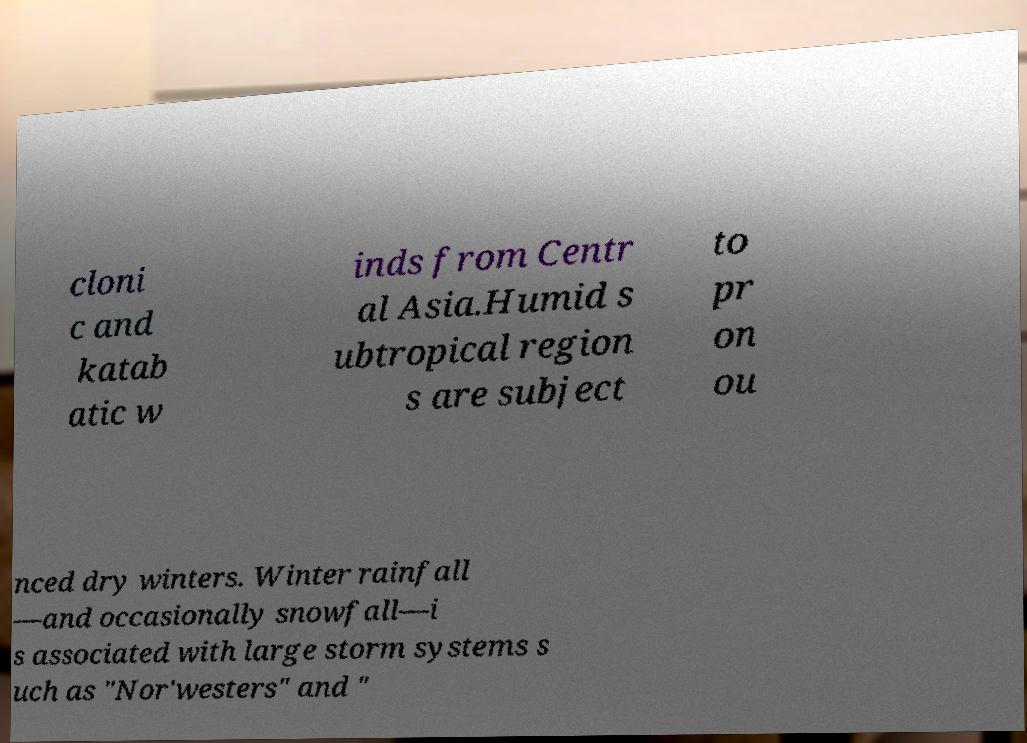Please identify and transcribe the text found in this image. cloni c and katab atic w inds from Centr al Asia.Humid s ubtropical region s are subject to pr on ou nced dry winters. Winter rainfall —and occasionally snowfall—i s associated with large storm systems s uch as "Nor'westers" and " 